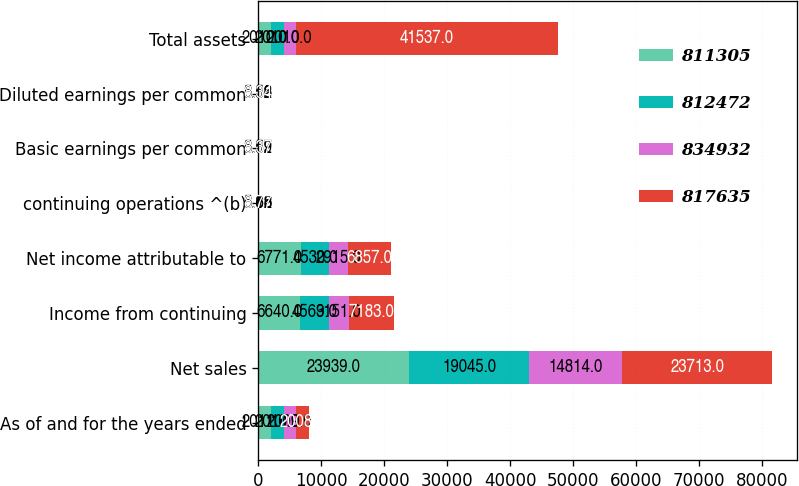<chart> <loc_0><loc_0><loc_500><loc_500><stacked_bar_chart><ecel><fcel>As of and for the years ended<fcel>Net sales<fcel>Income from continuing<fcel>Net income attributable to<fcel>continuing operations ^(b)<fcel>Basic earnings per common<fcel>Diluted earnings per common<fcel>Total assets<nl><fcel>811305<fcel>2011<fcel>23939<fcel>6640<fcel>6771<fcel>8.16<fcel>8.32<fcel>8.32<fcel>2010<nl><fcel>812472<fcel>2010<fcel>19045<fcel>4569<fcel>4530<fcel>5.62<fcel>5.57<fcel>5.56<fcel>2010<nl><fcel>834932<fcel>2009<fcel>14814<fcel>3151<fcel>2915<fcel>3.88<fcel>3.59<fcel>3.58<fcel>2010<nl><fcel>817635<fcel>2008<fcel>23713<fcel>7183<fcel>6857<fcel>8.77<fcel>8.37<fcel>8.34<fcel>41537<nl></chart> 